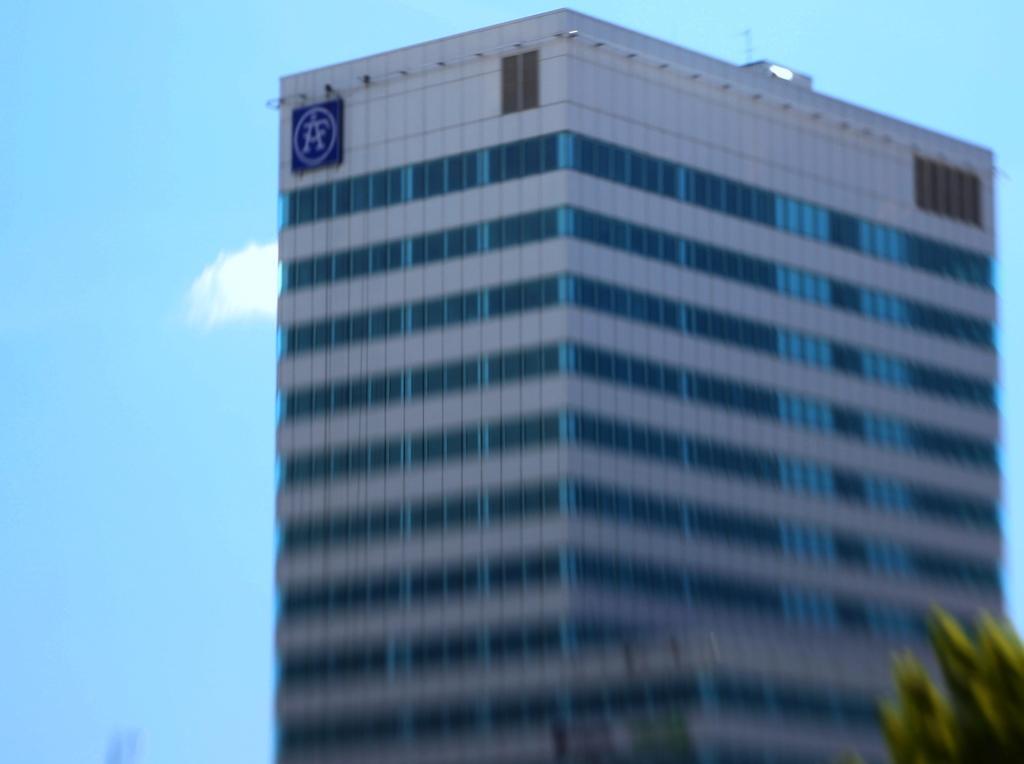How would you summarize this image in a sentence or two? In this image I can see a building and the sky visible in the backside of the building. 